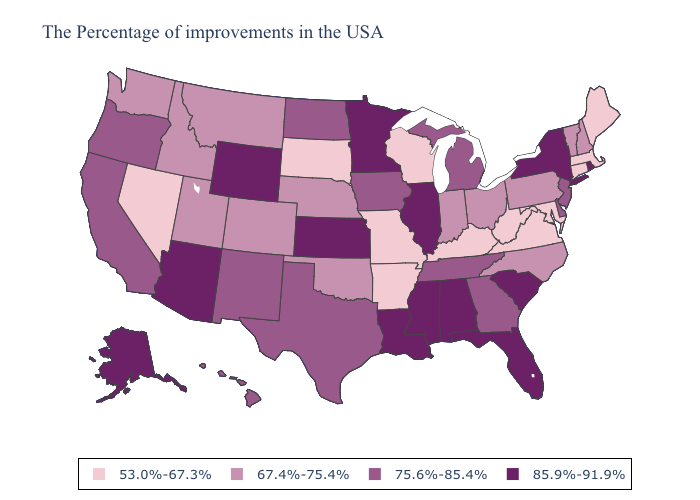Does Nebraska have the lowest value in the USA?
Be succinct. No. What is the value of Arkansas?
Be succinct. 53.0%-67.3%. Among the states that border Mississippi , which have the highest value?
Short answer required. Alabama, Louisiana. Name the states that have a value in the range 85.9%-91.9%?
Answer briefly. Rhode Island, New York, South Carolina, Florida, Alabama, Illinois, Mississippi, Louisiana, Minnesota, Kansas, Wyoming, Arizona, Alaska. Name the states that have a value in the range 75.6%-85.4%?
Write a very short answer. New Jersey, Delaware, Georgia, Michigan, Tennessee, Iowa, Texas, North Dakota, New Mexico, California, Oregon, Hawaii. Name the states that have a value in the range 67.4%-75.4%?
Concise answer only. New Hampshire, Vermont, Pennsylvania, North Carolina, Ohio, Indiana, Nebraska, Oklahoma, Colorado, Utah, Montana, Idaho, Washington. Among the states that border Kentucky , which have the lowest value?
Quick response, please. Virginia, West Virginia, Missouri. What is the value of Maine?
Be succinct. 53.0%-67.3%. Is the legend a continuous bar?
Give a very brief answer. No. What is the lowest value in states that border Utah?
Quick response, please. 53.0%-67.3%. What is the value of Georgia?
Give a very brief answer. 75.6%-85.4%. Name the states that have a value in the range 85.9%-91.9%?
Concise answer only. Rhode Island, New York, South Carolina, Florida, Alabama, Illinois, Mississippi, Louisiana, Minnesota, Kansas, Wyoming, Arizona, Alaska. Name the states that have a value in the range 85.9%-91.9%?
Keep it brief. Rhode Island, New York, South Carolina, Florida, Alabama, Illinois, Mississippi, Louisiana, Minnesota, Kansas, Wyoming, Arizona, Alaska. Name the states that have a value in the range 85.9%-91.9%?
Give a very brief answer. Rhode Island, New York, South Carolina, Florida, Alabama, Illinois, Mississippi, Louisiana, Minnesota, Kansas, Wyoming, Arizona, Alaska. 